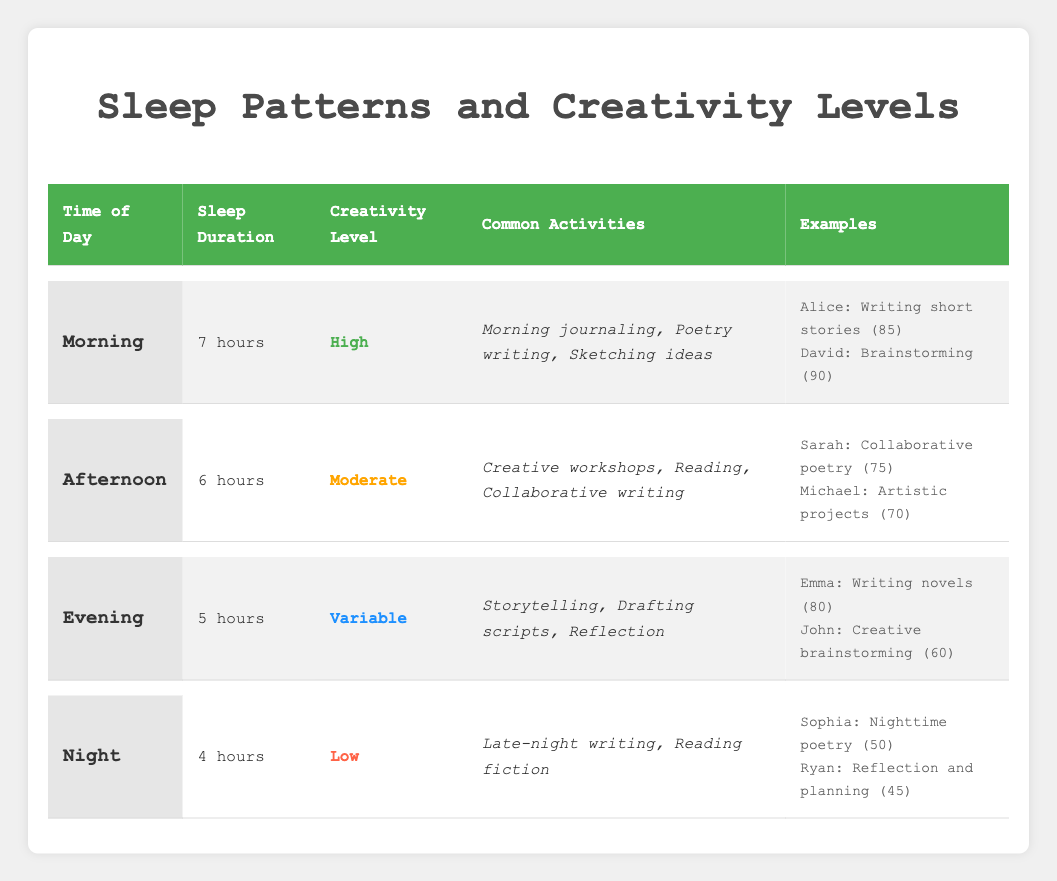What is the sleep duration during the morning? The table directly states that the sleep duration during the morning is 7 hours.
Answer: 7 hours Which time of day has the highest creativity level? According to the table, the morning has the highest creativity level marked as "High".
Answer: Morning What are the common activities during the evening? The table lists the common activities during the evening as storytelling, drafting scripts, and reflection.
Answer: Storytelling, drafting scripts, reflection What is the productivity score of Emma? Referring to the examples under the evening section of the table, Emma's productivity score is 80.
Answer: 80 How many hours of sleep are reported for the afternoon? The information presented in the table indicates that the sleep duration in the afternoon is 6 hours.
Answer: 6 hours Is the creativity level in the night higher than in the afternoon? The night has a creativity level of "Low," whereas the afternoon has a "Moderate" creativity level. Thus, it is false that the night is higher than the afternoon.
Answer: No What is the average productivity score of individuals who engage in creative activities in the afternoon and evening? The productivity scores in the afternoon (Sarah: 75, Michael: 70) average to (75 + 70) / 2 = 72.5. The evening scores (Emma: 80, John: 60) average to (80 + 60) / 2 = 70. Therefore, the overall average (72.5 + 70) / 2 = 71.25.
Answer: 71.25 Which time of day has the least common activities listed? The night has the least common activities mentioned with only "Late-night writing" and "Reading fiction," as compared to other times.
Answer: Night What is the difference in productivity scores between David and Sophia? David's productivity score is 90, and Sophia's score is 50. The difference is calculated as 90 - 50 = 40.
Answer: 40 